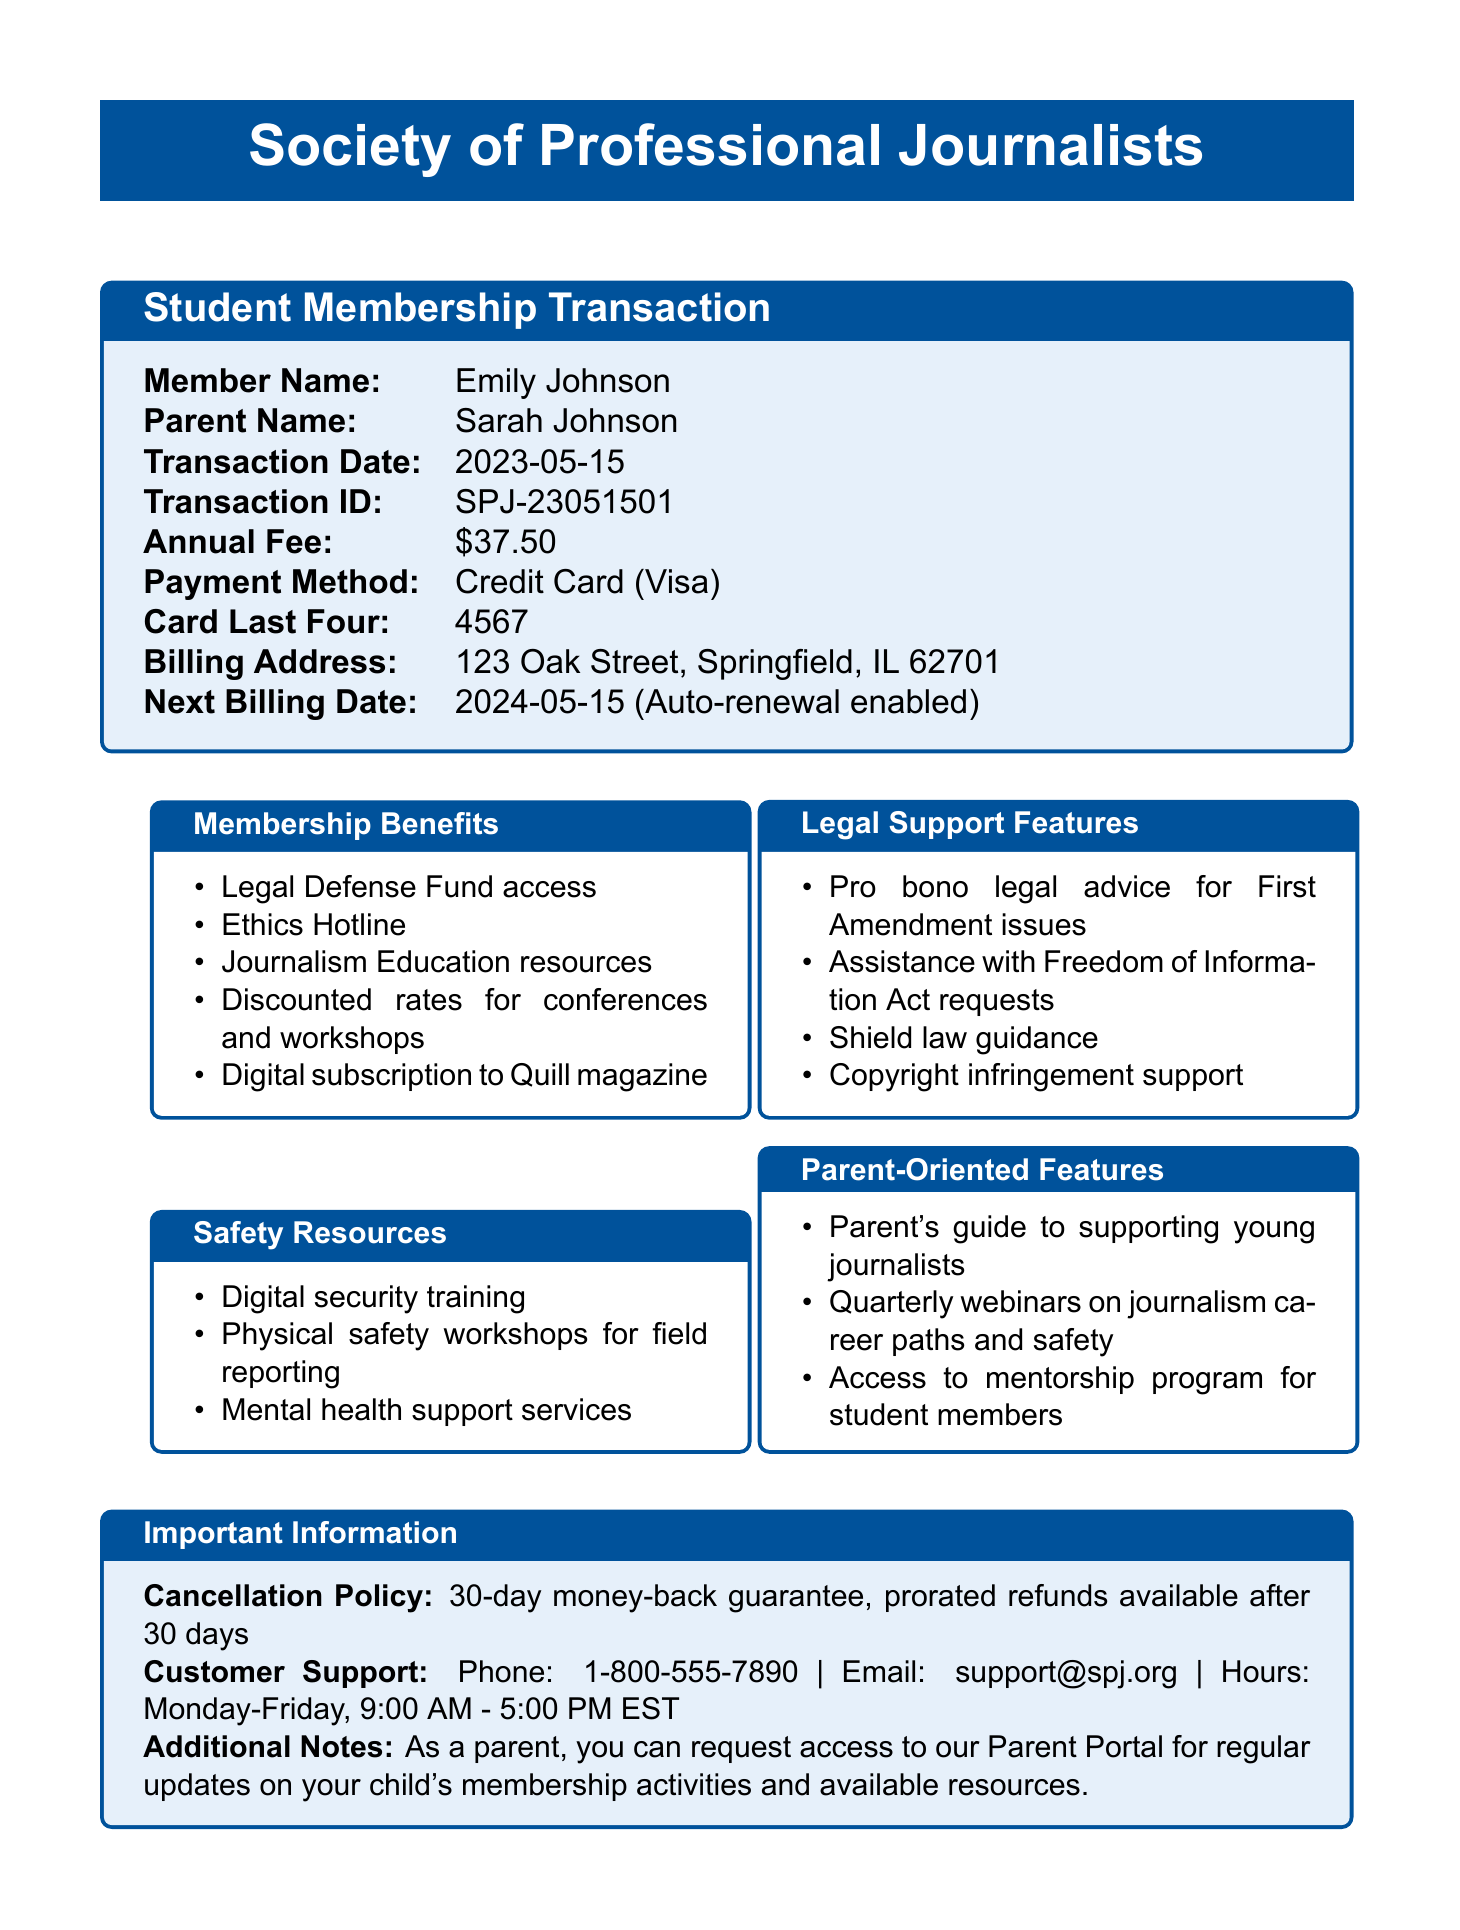What is the membership type? The membership type for Emily Johnson is specified in the document as "Student Membership."
Answer: Student Membership What is the annual fee? The annual fee for the Student Membership is clearly stated as $37.50.
Answer: $37.50 What are the benefits included in the membership? The document lists several benefits such as "Legal Defense Fund access" and "Ethics Hotline" among others.
Answer: Legal Defense Fund access, Ethics Hotline, Journalism Education resources, Discounted rates for conferences and workshops, Digital subscription to Quill magazine What legal support is offered? The document provides details about the legal support features available to members, like "Pro bono legal advice for First Amendment issues."
Answer: Pro bono legal advice for First Amendment issues What is the cancellation policy? The cancellation policy is explicitly mentioned in the document as "30-day money-back guarantee, prorated refunds available after 30 days."
Answer: 30-day money-back guarantee, prorated refunds available after 30 days When is the next billing date? The next billing date is indicated in the document as "2024-05-15."
Answer: 2024-05-15 What features are oriented towards parents? The document lists specific resources for parents, including the "Parent's guide to supporting young journalists."
Answer: Parent's guide to supporting young journalists What are the customer support hours? The hours for customer support are stated in the document as "Monday-Friday, 9:00 AM - 5:00 PM EST."
Answer: Monday-Friday, 9:00 AM - 5:00 PM EST Is auto-renewal enabled? The document clearly indicates that auto-renewal is enabled for the membership.
Answer: Yes 